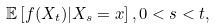Convert formula to latex. <formula><loc_0><loc_0><loc_500><loc_500>\mathbb { E } \left [ f ( X _ { t } ) | X _ { s } = x \right ] , 0 < s < t ,</formula> 